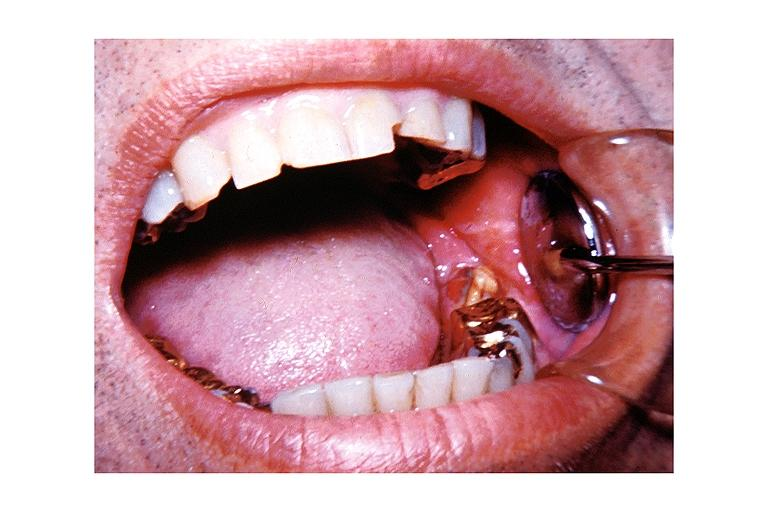does this image show chronic osteomyelitis?
Answer the question using a single word or phrase. Yes 